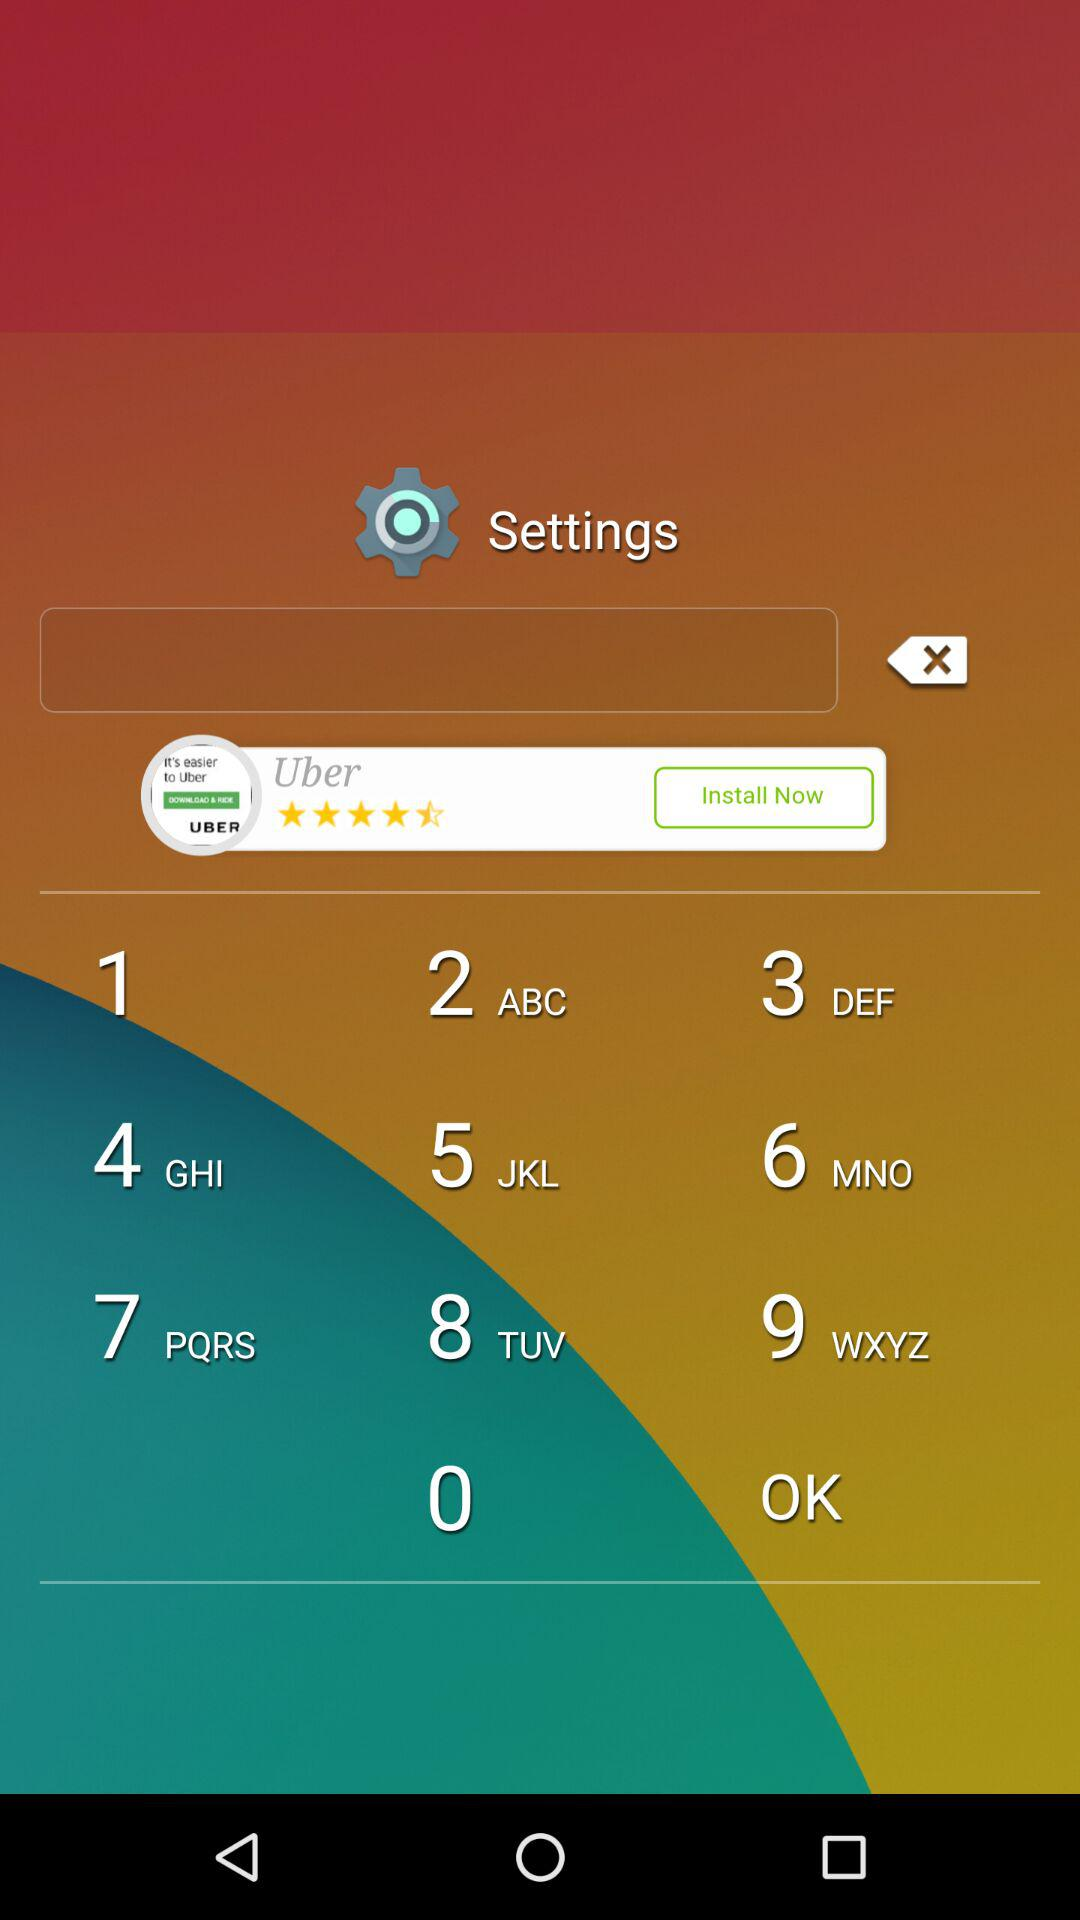Which scary sound is selected? The selected scary sound is "No sound". 